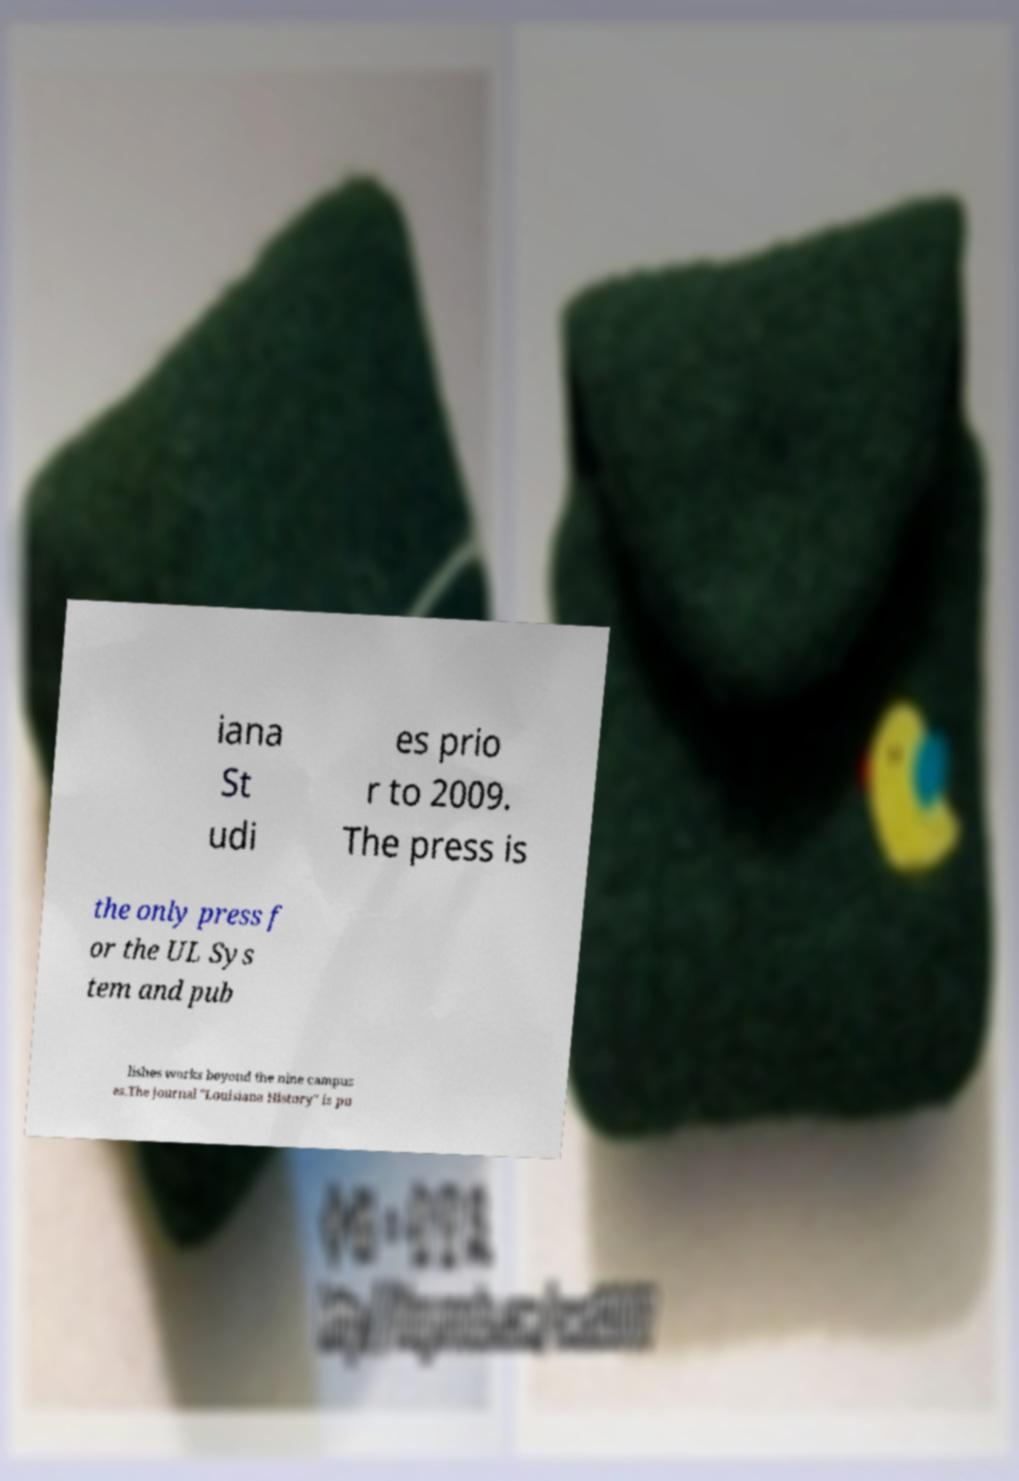What messages or text are displayed in this image? I need them in a readable, typed format. iana St udi es prio r to 2009. The press is the only press f or the UL Sys tem and pub lishes works beyond the nine campus es.The journal "Louisiana History" is pu 